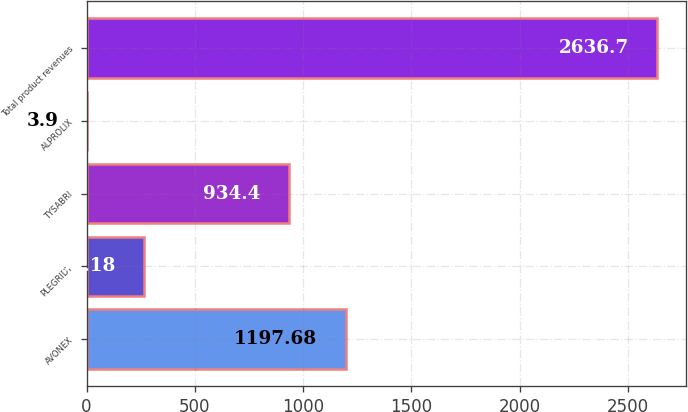Convert chart. <chart><loc_0><loc_0><loc_500><loc_500><bar_chart><fcel>AVONEX<fcel>PLEGRIDY<fcel>TYSABRI<fcel>ALPROLIX<fcel>Total product revenues<nl><fcel>1197.68<fcel>267.18<fcel>934.4<fcel>3.9<fcel>2636.7<nl></chart> 